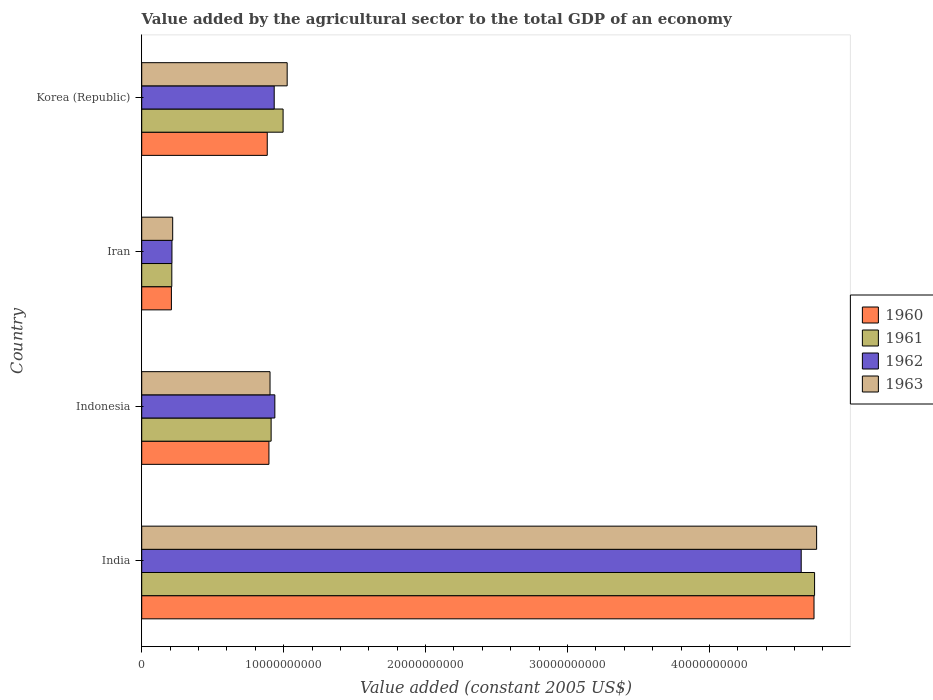Are the number of bars per tick equal to the number of legend labels?
Your response must be concise. Yes. Are the number of bars on each tick of the Y-axis equal?
Your answer should be very brief. Yes. What is the label of the 2nd group of bars from the top?
Provide a succinct answer. Iran. What is the value added by the agricultural sector in 1962 in Iran?
Offer a very short reply. 2.13e+09. Across all countries, what is the maximum value added by the agricultural sector in 1962?
Keep it short and to the point. 4.65e+1. Across all countries, what is the minimum value added by the agricultural sector in 1960?
Make the answer very short. 2.09e+09. In which country was the value added by the agricultural sector in 1963 maximum?
Your response must be concise. India. In which country was the value added by the agricultural sector in 1961 minimum?
Provide a succinct answer. Iran. What is the total value added by the agricultural sector in 1961 in the graph?
Provide a succinct answer. 6.86e+1. What is the difference between the value added by the agricultural sector in 1960 in Iran and that in Korea (Republic)?
Make the answer very short. -6.75e+09. What is the difference between the value added by the agricultural sector in 1962 in India and the value added by the agricultural sector in 1960 in Iran?
Provide a succinct answer. 4.44e+1. What is the average value added by the agricultural sector in 1960 per country?
Keep it short and to the point. 1.68e+1. What is the difference between the value added by the agricultural sector in 1962 and value added by the agricultural sector in 1961 in Korea (Republic)?
Offer a very short reply. -6.27e+08. In how many countries, is the value added by the agricultural sector in 1960 greater than 42000000000 US$?
Your response must be concise. 1. What is the ratio of the value added by the agricultural sector in 1961 in India to that in Indonesia?
Ensure brevity in your answer.  5.2. What is the difference between the highest and the second highest value added by the agricultural sector in 1963?
Your response must be concise. 3.73e+1. What is the difference between the highest and the lowest value added by the agricultural sector in 1963?
Ensure brevity in your answer.  4.54e+1. In how many countries, is the value added by the agricultural sector in 1960 greater than the average value added by the agricultural sector in 1960 taken over all countries?
Keep it short and to the point. 1. What does the 3rd bar from the bottom in Iran represents?
Make the answer very short. 1962. Is it the case that in every country, the sum of the value added by the agricultural sector in 1961 and value added by the agricultural sector in 1963 is greater than the value added by the agricultural sector in 1960?
Offer a very short reply. Yes. Are the values on the major ticks of X-axis written in scientific E-notation?
Offer a very short reply. No. Does the graph contain grids?
Keep it short and to the point. No. How are the legend labels stacked?
Keep it short and to the point. Vertical. What is the title of the graph?
Your answer should be very brief. Value added by the agricultural sector to the total GDP of an economy. What is the label or title of the X-axis?
Provide a succinct answer. Value added (constant 2005 US$). What is the label or title of the Y-axis?
Provide a short and direct response. Country. What is the Value added (constant 2005 US$) of 1960 in India?
Give a very brief answer. 4.74e+1. What is the Value added (constant 2005 US$) of 1961 in India?
Ensure brevity in your answer.  4.74e+1. What is the Value added (constant 2005 US$) in 1962 in India?
Your response must be concise. 4.65e+1. What is the Value added (constant 2005 US$) in 1963 in India?
Your answer should be very brief. 4.76e+1. What is the Value added (constant 2005 US$) of 1960 in Indonesia?
Provide a short and direct response. 8.96e+09. What is the Value added (constant 2005 US$) in 1961 in Indonesia?
Give a very brief answer. 9.12e+09. What is the Value added (constant 2005 US$) in 1962 in Indonesia?
Provide a short and direct response. 9.38e+09. What is the Value added (constant 2005 US$) of 1963 in Indonesia?
Your answer should be compact. 9.04e+09. What is the Value added (constant 2005 US$) of 1960 in Iran?
Give a very brief answer. 2.09e+09. What is the Value added (constant 2005 US$) of 1961 in Iran?
Give a very brief answer. 2.12e+09. What is the Value added (constant 2005 US$) in 1962 in Iran?
Provide a short and direct response. 2.13e+09. What is the Value added (constant 2005 US$) of 1963 in Iran?
Offer a very short reply. 2.18e+09. What is the Value added (constant 2005 US$) of 1960 in Korea (Republic)?
Offer a terse response. 8.84e+09. What is the Value added (constant 2005 US$) in 1961 in Korea (Republic)?
Your answer should be compact. 9.96e+09. What is the Value added (constant 2005 US$) in 1962 in Korea (Republic)?
Provide a succinct answer. 9.33e+09. What is the Value added (constant 2005 US$) in 1963 in Korea (Republic)?
Your response must be concise. 1.02e+1. Across all countries, what is the maximum Value added (constant 2005 US$) in 1960?
Your answer should be very brief. 4.74e+1. Across all countries, what is the maximum Value added (constant 2005 US$) in 1961?
Your answer should be very brief. 4.74e+1. Across all countries, what is the maximum Value added (constant 2005 US$) in 1962?
Keep it short and to the point. 4.65e+1. Across all countries, what is the maximum Value added (constant 2005 US$) of 1963?
Offer a very short reply. 4.76e+1. Across all countries, what is the minimum Value added (constant 2005 US$) of 1960?
Offer a terse response. 2.09e+09. Across all countries, what is the minimum Value added (constant 2005 US$) of 1961?
Give a very brief answer. 2.12e+09. Across all countries, what is the minimum Value added (constant 2005 US$) in 1962?
Your answer should be very brief. 2.13e+09. Across all countries, what is the minimum Value added (constant 2005 US$) of 1963?
Your answer should be very brief. 2.18e+09. What is the total Value added (constant 2005 US$) in 1960 in the graph?
Keep it short and to the point. 6.73e+1. What is the total Value added (constant 2005 US$) of 1961 in the graph?
Keep it short and to the point. 6.86e+1. What is the total Value added (constant 2005 US$) in 1962 in the graph?
Your answer should be very brief. 6.73e+1. What is the total Value added (constant 2005 US$) of 1963 in the graph?
Provide a succinct answer. 6.90e+1. What is the difference between the Value added (constant 2005 US$) in 1960 in India and that in Indonesia?
Provide a short and direct response. 3.84e+1. What is the difference between the Value added (constant 2005 US$) in 1961 in India and that in Indonesia?
Make the answer very short. 3.83e+1. What is the difference between the Value added (constant 2005 US$) in 1962 in India and that in Indonesia?
Your response must be concise. 3.71e+1. What is the difference between the Value added (constant 2005 US$) in 1963 in India and that in Indonesia?
Give a very brief answer. 3.85e+1. What is the difference between the Value added (constant 2005 US$) in 1960 in India and that in Iran?
Offer a terse response. 4.53e+1. What is the difference between the Value added (constant 2005 US$) in 1961 in India and that in Iran?
Make the answer very short. 4.53e+1. What is the difference between the Value added (constant 2005 US$) in 1962 in India and that in Iran?
Offer a terse response. 4.43e+1. What is the difference between the Value added (constant 2005 US$) in 1963 in India and that in Iran?
Your response must be concise. 4.54e+1. What is the difference between the Value added (constant 2005 US$) of 1960 in India and that in Korea (Republic)?
Your answer should be very brief. 3.85e+1. What is the difference between the Value added (constant 2005 US$) in 1961 in India and that in Korea (Republic)?
Give a very brief answer. 3.74e+1. What is the difference between the Value added (constant 2005 US$) of 1962 in India and that in Korea (Republic)?
Give a very brief answer. 3.71e+1. What is the difference between the Value added (constant 2005 US$) of 1963 in India and that in Korea (Republic)?
Give a very brief answer. 3.73e+1. What is the difference between the Value added (constant 2005 US$) of 1960 in Indonesia and that in Iran?
Your answer should be compact. 6.87e+09. What is the difference between the Value added (constant 2005 US$) of 1961 in Indonesia and that in Iran?
Your response must be concise. 7.00e+09. What is the difference between the Value added (constant 2005 US$) of 1962 in Indonesia and that in Iran?
Your answer should be very brief. 7.25e+09. What is the difference between the Value added (constant 2005 US$) of 1963 in Indonesia and that in Iran?
Provide a short and direct response. 6.86e+09. What is the difference between the Value added (constant 2005 US$) in 1960 in Indonesia and that in Korea (Republic)?
Your answer should be compact. 1.19e+08. What is the difference between the Value added (constant 2005 US$) in 1961 in Indonesia and that in Korea (Republic)?
Keep it short and to the point. -8.44e+08. What is the difference between the Value added (constant 2005 US$) in 1962 in Indonesia and that in Korea (Republic)?
Provide a short and direct response. 4.52e+07. What is the difference between the Value added (constant 2005 US$) of 1963 in Indonesia and that in Korea (Republic)?
Your answer should be compact. -1.21e+09. What is the difference between the Value added (constant 2005 US$) of 1960 in Iran and that in Korea (Republic)?
Ensure brevity in your answer.  -6.75e+09. What is the difference between the Value added (constant 2005 US$) of 1961 in Iran and that in Korea (Republic)?
Keep it short and to the point. -7.84e+09. What is the difference between the Value added (constant 2005 US$) of 1962 in Iran and that in Korea (Republic)?
Provide a short and direct response. -7.20e+09. What is the difference between the Value added (constant 2005 US$) in 1963 in Iran and that in Korea (Republic)?
Make the answer very short. -8.07e+09. What is the difference between the Value added (constant 2005 US$) of 1960 in India and the Value added (constant 2005 US$) of 1961 in Indonesia?
Your answer should be very brief. 3.83e+1. What is the difference between the Value added (constant 2005 US$) in 1960 in India and the Value added (constant 2005 US$) in 1962 in Indonesia?
Your response must be concise. 3.80e+1. What is the difference between the Value added (constant 2005 US$) in 1960 in India and the Value added (constant 2005 US$) in 1963 in Indonesia?
Provide a succinct answer. 3.83e+1. What is the difference between the Value added (constant 2005 US$) of 1961 in India and the Value added (constant 2005 US$) of 1962 in Indonesia?
Keep it short and to the point. 3.80e+1. What is the difference between the Value added (constant 2005 US$) of 1961 in India and the Value added (constant 2005 US$) of 1963 in Indonesia?
Offer a very short reply. 3.84e+1. What is the difference between the Value added (constant 2005 US$) of 1962 in India and the Value added (constant 2005 US$) of 1963 in Indonesia?
Your answer should be very brief. 3.74e+1. What is the difference between the Value added (constant 2005 US$) of 1960 in India and the Value added (constant 2005 US$) of 1961 in Iran?
Ensure brevity in your answer.  4.52e+1. What is the difference between the Value added (constant 2005 US$) of 1960 in India and the Value added (constant 2005 US$) of 1962 in Iran?
Your answer should be compact. 4.52e+1. What is the difference between the Value added (constant 2005 US$) of 1960 in India and the Value added (constant 2005 US$) of 1963 in Iran?
Give a very brief answer. 4.52e+1. What is the difference between the Value added (constant 2005 US$) in 1961 in India and the Value added (constant 2005 US$) in 1962 in Iran?
Make the answer very short. 4.53e+1. What is the difference between the Value added (constant 2005 US$) of 1961 in India and the Value added (constant 2005 US$) of 1963 in Iran?
Your answer should be very brief. 4.52e+1. What is the difference between the Value added (constant 2005 US$) of 1962 in India and the Value added (constant 2005 US$) of 1963 in Iran?
Provide a succinct answer. 4.43e+1. What is the difference between the Value added (constant 2005 US$) of 1960 in India and the Value added (constant 2005 US$) of 1961 in Korea (Republic)?
Keep it short and to the point. 3.74e+1. What is the difference between the Value added (constant 2005 US$) of 1960 in India and the Value added (constant 2005 US$) of 1962 in Korea (Republic)?
Your answer should be very brief. 3.80e+1. What is the difference between the Value added (constant 2005 US$) in 1960 in India and the Value added (constant 2005 US$) in 1963 in Korea (Republic)?
Your answer should be very brief. 3.71e+1. What is the difference between the Value added (constant 2005 US$) of 1961 in India and the Value added (constant 2005 US$) of 1962 in Korea (Republic)?
Ensure brevity in your answer.  3.81e+1. What is the difference between the Value added (constant 2005 US$) of 1961 in India and the Value added (constant 2005 US$) of 1963 in Korea (Republic)?
Make the answer very short. 3.72e+1. What is the difference between the Value added (constant 2005 US$) in 1962 in India and the Value added (constant 2005 US$) in 1963 in Korea (Republic)?
Provide a succinct answer. 3.62e+1. What is the difference between the Value added (constant 2005 US$) of 1960 in Indonesia and the Value added (constant 2005 US$) of 1961 in Iran?
Keep it short and to the point. 6.84e+09. What is the difference between the Value added (constant 2005 US$) of 1960 in Indonesia and the Value added (constant 2005 US$) of 1962 in Iran?
Your response must be concise. 6.83e+09. What is the difference between the Value added (constant 2005 US$) in 1960 in Indonesia and the Value added (constant 2005 US$) in 1963 in Iran?
Ensure brevity in your answer.  6.78e+09. What is the difference between the Value added (constant 2005 US$) of 1961 in Indonesia and the Value added (constant 2005 US$) of 1962 in Iran?
Your answer should be compact. 6.99e+09. What is the difference between the Value added (constant 2005 US$) of 1961 in Indonesia and the Value added (constant 2005 US$) of 1963 in Iran?
Ensure brevity in your answer.  6.94e+09. What is the difference between the Value added (constant 2005 US$) of 1962 in Indonesia and the Value added (constant 2005 US$) of 1963 in Iran?
Your answer should be very brief. 7.20e+09. What is the difference between the Value added (constant 2005 US$) in 1960 in Indonesia and the Value added (constant 2005 US$) in 1961 in Korea (Republic)?
Make the answer very short. -9.98e+08. What is the difference between the Value added (constant 2005 US$) in 1960 in Indonesia and the Value added (constant 2005 US$) in 1962 in Korea (Republic)?
Keep it short and to the point. -3.71e+08. What is the difference between the Value added (constant 2005 US$) of 1960 in Indonesia and the Value added (constant 2005 US$) of 1963 in Korea (Republic)?
Provide a short and direct response. -1.28e+09. What is the difference between the Value added (constant 2005 US$) in 1961 in Indonesia and the Value added (constant 2005 US$) in 1962 in Korea (Republic)?
Your answer should be very brief. -2.17e+08. What is the difference between the Value added (constant 2005 US$) in 1961 in Indonesia and the Value added (constant 2005 US$) in 1963 in Korea (Republic)?
Your answer should be very brief. -1.13e+09. What is the difference between the Value added (constant 2005 US$) in 1962 in Indonesia and the Value added (constant 2005 US$) in 1963 in Korea (Republic)?
Provide a succinct answer. -8.69e+08. What is the difference between the Value added (constant 2005 US$) of 1960 in Iran and the Value added (constant 2005 US$) of 1961 in Korea (Republic)?
Your response must be concise. -7.87e+09. What is the difference between the Value added (constant 2005 US$) of 1960 in Iran and the Value added (constant 2005 US$) of 1962 in Korea (Republic)?
Give a very brief answer. -7.24e+09. What is the difference between the Value added (constant 2005 US$) in 1960 in Iran and the Value added (constant 2005 US$) in 1963 in Korea (Republic)?
Your answer should be very brief. -8.16e+09. What is the difference between the Value added (constant 2005 US$) of 1961 in Iran and the Value added (constant 2005 US$) of 1962 in Korea (Republic)?
Your answer should be compact. -7.21e+09. What is the difference between the Value added (constant 2005 US$) in 1961 in Iran and the Value added (constant 2005 US$) in 1963 in Korea (Republic)?
Ensure brevity in your answer.  -8.13e+09. What is the difference between the Value added (constant 2005 US$) in 1962 in Iran and the Value added (constant 2005 US$) in 1963 in Korea (Republic)?
Ensure brevity in your answer.  -8.12e+09. What is the average Value added (constant 2005 US$) in 1960 per country?
Offer a terse response. 1.68e+1. What is the average Value added (constant 2005 US$) in 1961 per country?
Offer a very short reply. 1.72e+1. What is the average Value added (constant 2005 US$) of 1962 per country?
Offer a terse response. 1.68e+1. What is the average Value added (constant 2005 US$) in 1963 per country?
Your answer should be compact. 1.73e+1. What is the difference between the Value added (constant 2005 US$) of 1960 and Value added (constant 2005 US$) of 1961 in India?
Provide a short and direct response. -3.99e+07. What is the difference between the Value added (constant 2005 US$) in 1960 and Value added (constant 2005 US$) in 1962 in India?
Give a very brief answer. 9.03e+08. What is the difference between the Value added (constant 2005 US$) of 1960 and Value added (constant 2005 US$) of 1963 in India?
Offer a terse response. -1.84e+08. What is the difference between the Value added (constant 2005 US$) in 1961 and Value added (constant 2005 US$) in 1962 in India?
Your answer should be compact. 9.43e+08. What is the difference between the Value added (constant 2005 US$) in 1961 and Value added (constant 2005 US$) in 1963 in India?
Your answer should be compact. -1.44e+08. What is the difference between the Value added (constant 2005 US$) in 1962 and Value added (constant 2005 US$) in 1963 in India?
Your response must be concise. -1.09e+09. What is the difference between the Value added (constant 2005 US$) of 1960 and Value added (constant 2005 US$) of 1961 in Indonesia?
Your answer should be compact. -1.54e+08. What is the difference between the Value added (constant 2005 US$) of 1960 and Value added (constant 2005 US$) of 1962 in Indonesia?
Give a very brief answer. -4.16e+08. What is the difference between the Value added (constant 2005 US$) in 1960 and Value added (constant 2005 US$) in 1963 in Indonesia?
Your answer should be compact. -7.71e+07. What is the difference between the Value added (constant 2005 US$) in 1961 and Value added (constant 2005 US$) in 1962 in Indonesia?
Ensure brevity in your answer.  -2.62e+08. What is the difference between the Value added (constant 2005 US$) of 1961 and Value added (constant 2005 US$) of 1963 in Indonesia?
Your response must be concise. 7.71e+07. What is the difference between the Value added (constant 2005 US$) of 1962 and Value added (constant 2005 US$) of 1963 in Indonesia?
Your response must be concise. 3.39e+08. What is the difference between the Value added (constant 2005 US$) of 1960 and Value added (constant 2005 US$) of 1961 in Iran?
Your answer should be very brief. -2.84e+07. What is the difference between the Value added (constant 2005 US$) in 1960 and Value added (constant 2005 US$) in 1962 in Iran?
Give a very brief answer. -3.89e+07. What is the difference between the Value added (constant 2005 US$) in 1960 and Value added (constant 2005 US$) in 1963 in Iran?
Your answer should be compact. -9.02e+07. What is the difference between the Value added (constant 2005 US$) of 1961 and Value added (constant 2005 US$) of 1962 in Iran?
Provide a short and direct response. -1.05e+07. What is the difference between the Value added (constant 2005 US$) of 1961 and Value added (constant 2005 US$) of 1963 in Iran?
Your response must be concise. -6.18e+07. What is the difference between the Value added (constant 2005 US$) of 1962 and Value added (constant 2005 US$) of 1963 in Iran?
Provide a succinct answer. -5.13e+07. What is the difference between the Value added (constant 2005 US$) of 1960 and Value added (constant 2005 US$) of 1961 in Korea (Republic)?
Offer a terse response. -1.12e+09. What is the difference between the Value added (constant 2005 US$) of 1960 and Value added (constant 2005 US$) of 1962 in Korea (Republic)?
Offer a terse response. -4.90e+08. What is the difference between the Value added (constant 2005 US$) in 1960 and Value added (constant 2005 US$) in 1963 in Korea (Republic)?
Provide a succinct answer. -1.40e+09. What is the difference between the Value added (constant 2005 US$) in 1961 and Value added (constant 2005 US$) in 1962 in Korea (Republic)?
Your answer should be very brief. 6.27e+08. What is the difference between the Value added (constant 2005 US$) of 1961 and Value added (constant 2005 US$) of 1963 in Korea (Republic)?
Your answer should be compact. -2.87e+08. What is the difference between the Value added (constant 2005 US$) of 1962 and Value added (constant 2005 US$) of 1963 in Korea (Republic)?
Give a very brief answer. -9.14e+08. What is the ratio of the Value added (constant 2005 US$) of 1960 in India to that in Indonesia?
Give a very brief answer. 5.28. What is the ratio of the Value added (constant 2005 US$) of 1961 in India to that in Indonesia?
Your answer should be very brief. 5.2. What is the ratio of the Value added (constant 2005 US$) in 1962 in India to that in Indonesia?
Keep it short and to the point. 4.95. What is the ratio of the Value added (constant 2005 US$) in 1963 in India to that in Indonesia?
Your answer should be very brief. 5.26. What is the ratio of the Value added (constant 2005 US$) of 1960 in India to that in Iran?
Your response must be concise. 22.65. What is the ratio of the Value added (constant 2005 US$) of 1961 in India to that in Iran?
Make the answer very short. 22.37. What is the ratio of the Value added (constant 2005 US$) of 1962 in India to that in Iran?
Keep it short and to the point. 21.81. What is the ratio of the Value added (constant 2005 US$) of 1963 in India to that in Iran?
Give a very brief answer. 21.8. What is the ratio of the Value added (constant 2005 US$) of 1960 in India to that in Korea (Republic)?
Give a very brief answer. 5.36. What is the ratio of the Value added (constant 2005 US$) of 1961 in India to that in Korea (Republic)?
Make the answer very short. 4.76. What is the ratio of the Value added (constant 2005 US$) in 1962 in India to that in Korea (Republic)?
Provide a succinct answer. 4.98. What is the ratio of the Value added (constant 2005 US$) in 1963 in India to that in Korea (Republic)?
Offer a very short reply. 4.64. What is the ratio of the Value added (constant 2005 US$) of 1960 in Indonesia to that in Iran?
Ensure brevity in your answer.  4.29. What is the ratio of the Value added (constant 2005 US$) in 1961 in Indonesia to that in Iran?
Keep it short and to the point. 4.3. What is the ratio of the Value added (constant 2005 US$) in 1962 in Indonesia to that in Iran?
Offer a very short reply. 4.4. What is the ratio of the Value added (constant 2005 US$) in 1963 in Indonesia to that in Iran?
Ensure brevity in your answer.  4.14. What is the ratio of the Value added (constant 2005 US$) in 1960 in Indonesia to that in Korea (Republic)?
Keep it short and to the point. 1.01. What is the ratio of the Value added (constant 2005 US$) in 1961 in Indonesia to that in Korea (Republic)?
Offer a terse response. 0.92. What is the ratio of the Value added (constant 2005 US$) in 1963 in Indonesia to that in Korea (Republic)?
Offer a very short reply. 0.88. What is the ratio of the Value added (constant 2005 US$) in 1960 in Iran to that in Korea (Republic)?
Make the answer very short. 0.24. What is the ratio of the Value added (constant 2005 US$) in 1961 in Iran to that in Korea (Republic)?
Offer a terse response. 0.21. What is the ratio of the Value added (constant 2005 US$) of 1962 in Iran to that in Korea (Republic)?
Provide a succinct answer. 0.23. What is the ratio of the Value added (constant 2005 US$) in 1963 in Iran to that in Korea (Republic)?
Ensure brevity in your answer.  0.21. What is the difference between the highest and the second highest Value added (constant 2005 US$) of 1960?
Offer a very short reply. 3.84e+1. What is the difference between the highest and the second highest Value added (constant 2005 US$) of 1961?
Your answer should be very brief. 3.74e+1. What is the difference between the highest and the second highest Value added (constant 2005 US$) in 1962?
Offer a terse response. 3.71e+1. What is the difference between the highest and the second highest Value added (constant 2005 US$) of 1963?
Provide a short and direct response. 3.73e+1. What is the difference between the highest and the lowest Value added (constant 2005 US$) in 1960?
Your answer should be compact. 4.53e+1. What is the difference between the highest and the lowest Value added (constant 2005 US$) in 1961?
Your answer should be very brief. 4.53e+1. What is the difference between the highest and the lowest Value added (constant 2005 US$) of 1962?
Keep it short and to the point. 4.43e+1. What is the difference between the highest and the lowest Value added (constant 2005 US$) of 1963?
Provide a succinct answer. 4.54e+1. 